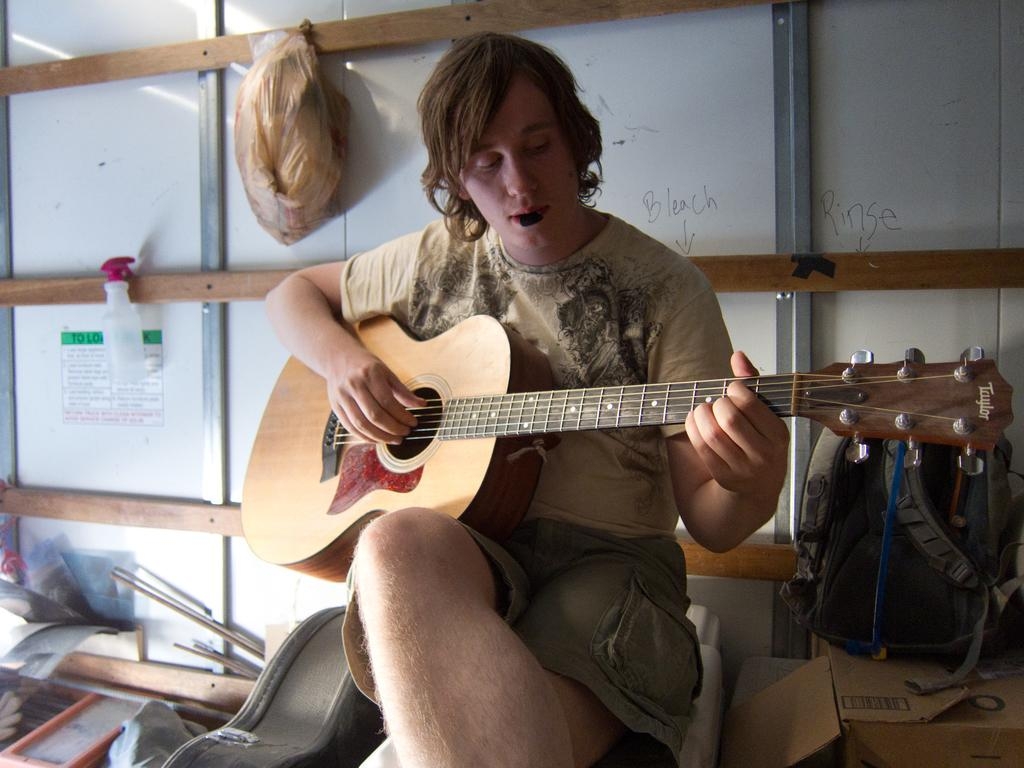Who is the person in the image? There is a man in the image. What is the man doing in the image? The man is playing a guitar. Where is the man located in the image? The man is sitting on a table. What type of form does the steam take in the image? There is no steam present in the image. How does the man's health appear in the image? The image does not provide any information about the man's health. 